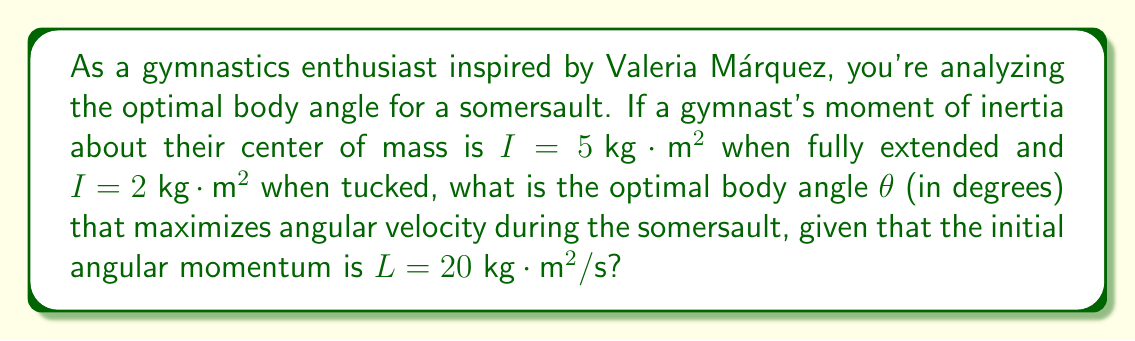Can you solve this math problem? Let's approach this step-by-step:

1) The relationship between angular momentum (L), moment of inertia (I), and angular velocity (ω) is given by:

   $$L = I\omega$$

2) We want to maximize ω, which means minimizing I (since L is constant).

3) The moment of inertia for an intermediate position can be modeled as:

   $$I(\theta) = I_{extended} \sin^2(\theta) + I_{tucked} \cos^2(\theta)$$

   Where θ is the angle between the body and the vertical axis.

4) Substituting the given values:

   $$I(\theta) = 5 \sin^2(\theta) + 2 \cos^2(\theta)$$

5) To find the minimum of I(θ), we differentiate and set it to zero:

   $$\frac{dI}{d\theta} = 10 \sin(\theta)\cos(\theta) - 4 \sin(\theta)\cos(\theta) = 0$$

6) Simplifying:

   $$6 \sin(\theta)\cos(\theta) = 0$$

7) This is true when $\sin(\theta) = 0$ or $\cos(\theta) = 0$. However, $\sin(\theta) = 0$ gives us the maximum I, not the minimum.

8) So, we want $\cos(\theta) = 0$, which occurs when $\theta = 90°$.

9) To confirm this is a minimum, we can check the second derivative is positive at this point.

Therefore, the optimal angle is 90° from the vertical, which corresponds to a fully extended position perpendicular to the axis of rotation.
Answer: 90° 